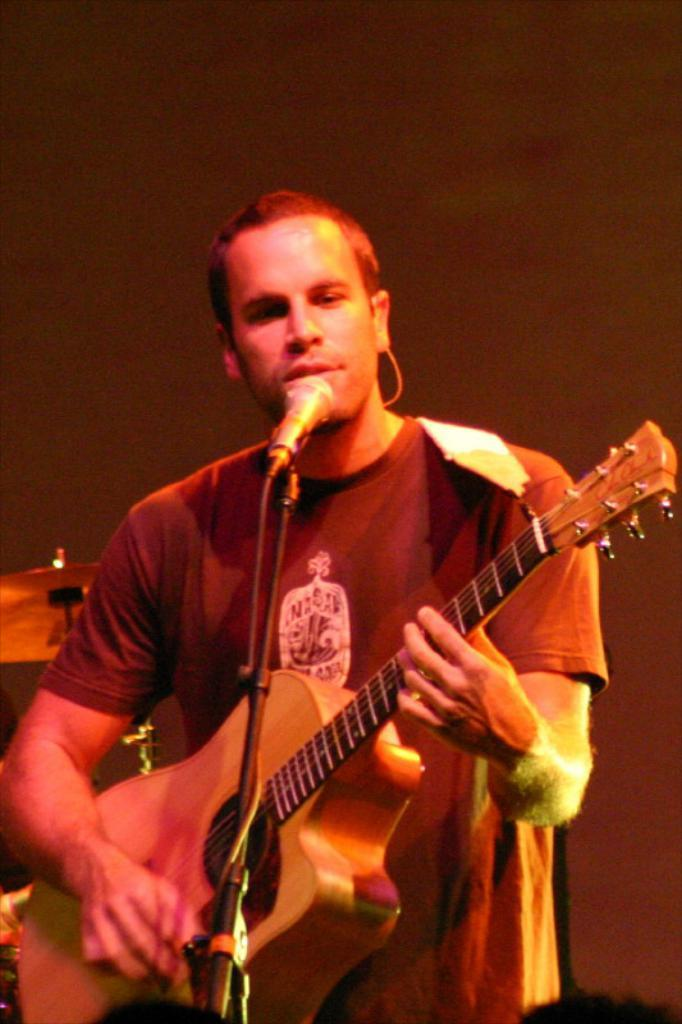What is the person in the image doing? The person is playing a guitar. What can be seen at the front of the image? There is a microphone at the front of the image. What other musical instrument is visible in the image? There are drums visible at the back of the image. How many goldfish are swimming in the background of the image? There are no goldfish present in the image. What type of seat is the person using while playing the guitar? The provided facts do not mention a seat, so it cannot be determined from the image. 